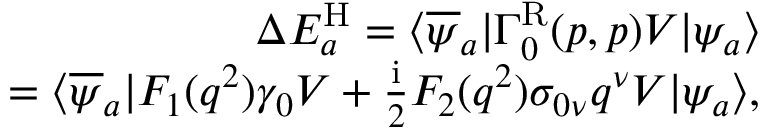Convert formula to latex. <formula><loc_0><loc_0><loc_500><loc_500>\begin{array} { r } { \Delta E _ { a } ^ { H } = \langle \overline { \psi } _ { a } | \Gamma _ { 0 } ^ { R } ( p , p ) V | \psi _ { a } \rangle } \\ { = \langle \overline { \psi } _ { a } | F _ { 1 } ( q ^ { 2 } ) \gamma _ { 0 } V + \frac { i } { 2 } F _ { 2 } ( q ^ { 2 } ) \sigma _ { 0 \nu } q ^ { \nu } V | \psi _ { a } \rangle , } \end{array}</formula> 